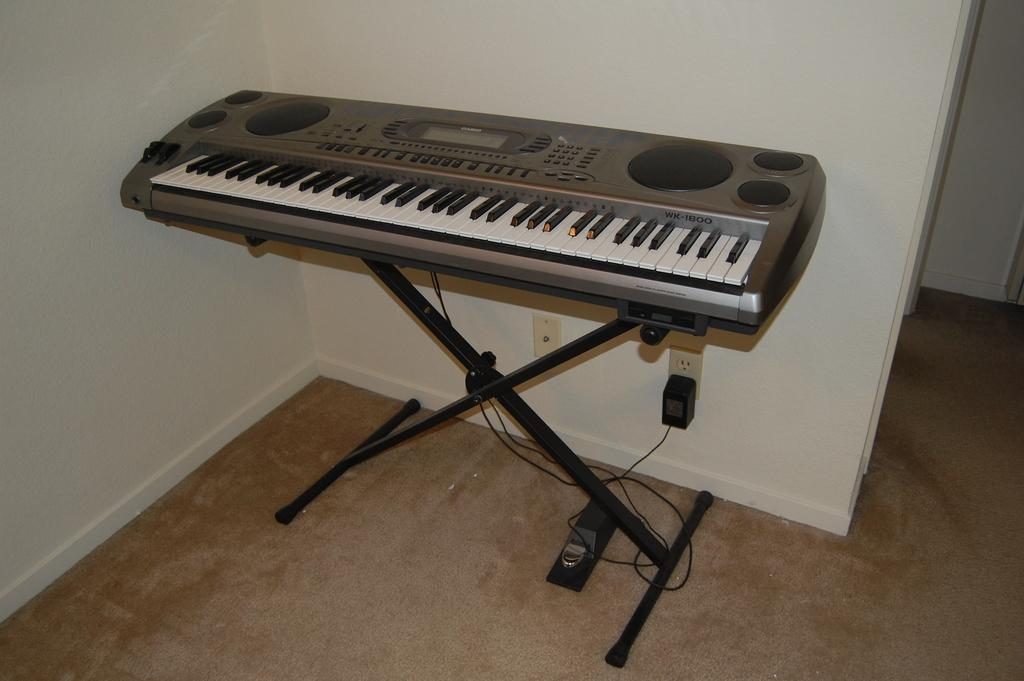What musical instrument is present in the image? There is a piano in the image. What is the color of the piano's stand? The piano's stand has a black color. How is the piano's stand supported? The stand is electrically supported by a socket. Is there a boat in the image? No, there is no boat present in the image. What is the chance of winning a prize in the image? There is no mention of a prize or chance in the image, as it features a piano with a black stand. 